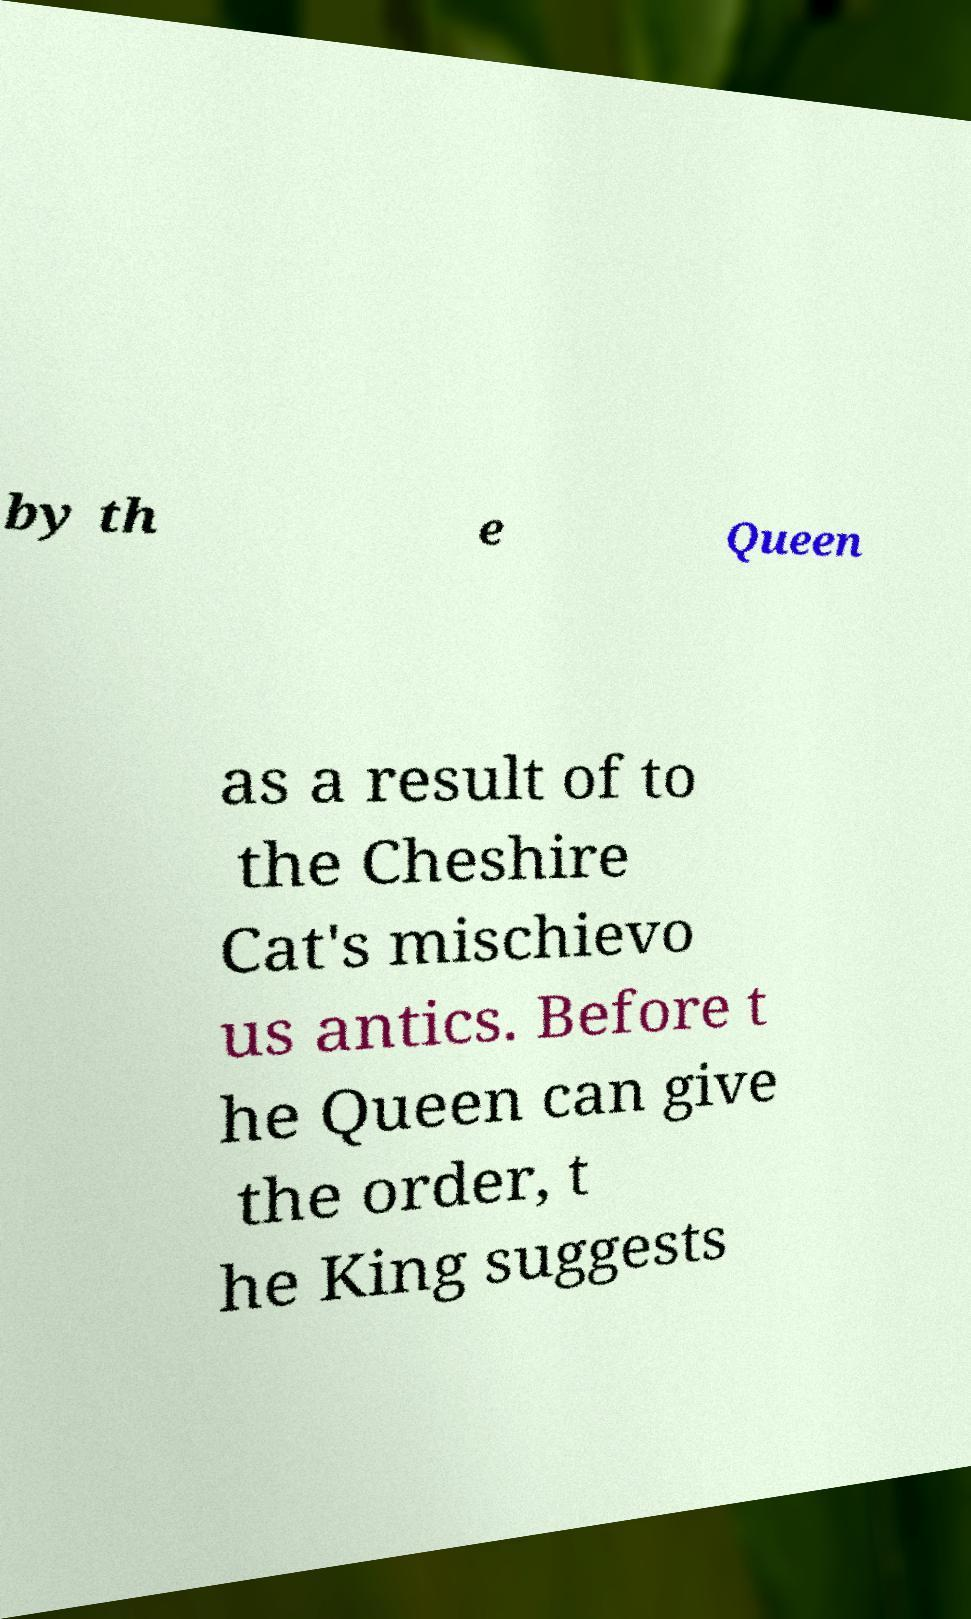Could you assist in decoding the text presented in this image and type it out clearly? by th e Queen as a result of to the Cheshire Cat's mischievo us antics. Before t he Queen can give the order, t he King suggests 